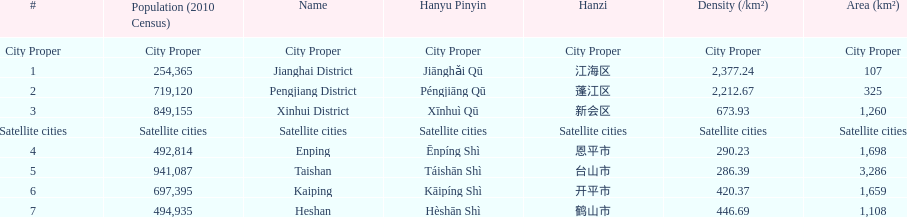Which area has the largest population? Taishan. 